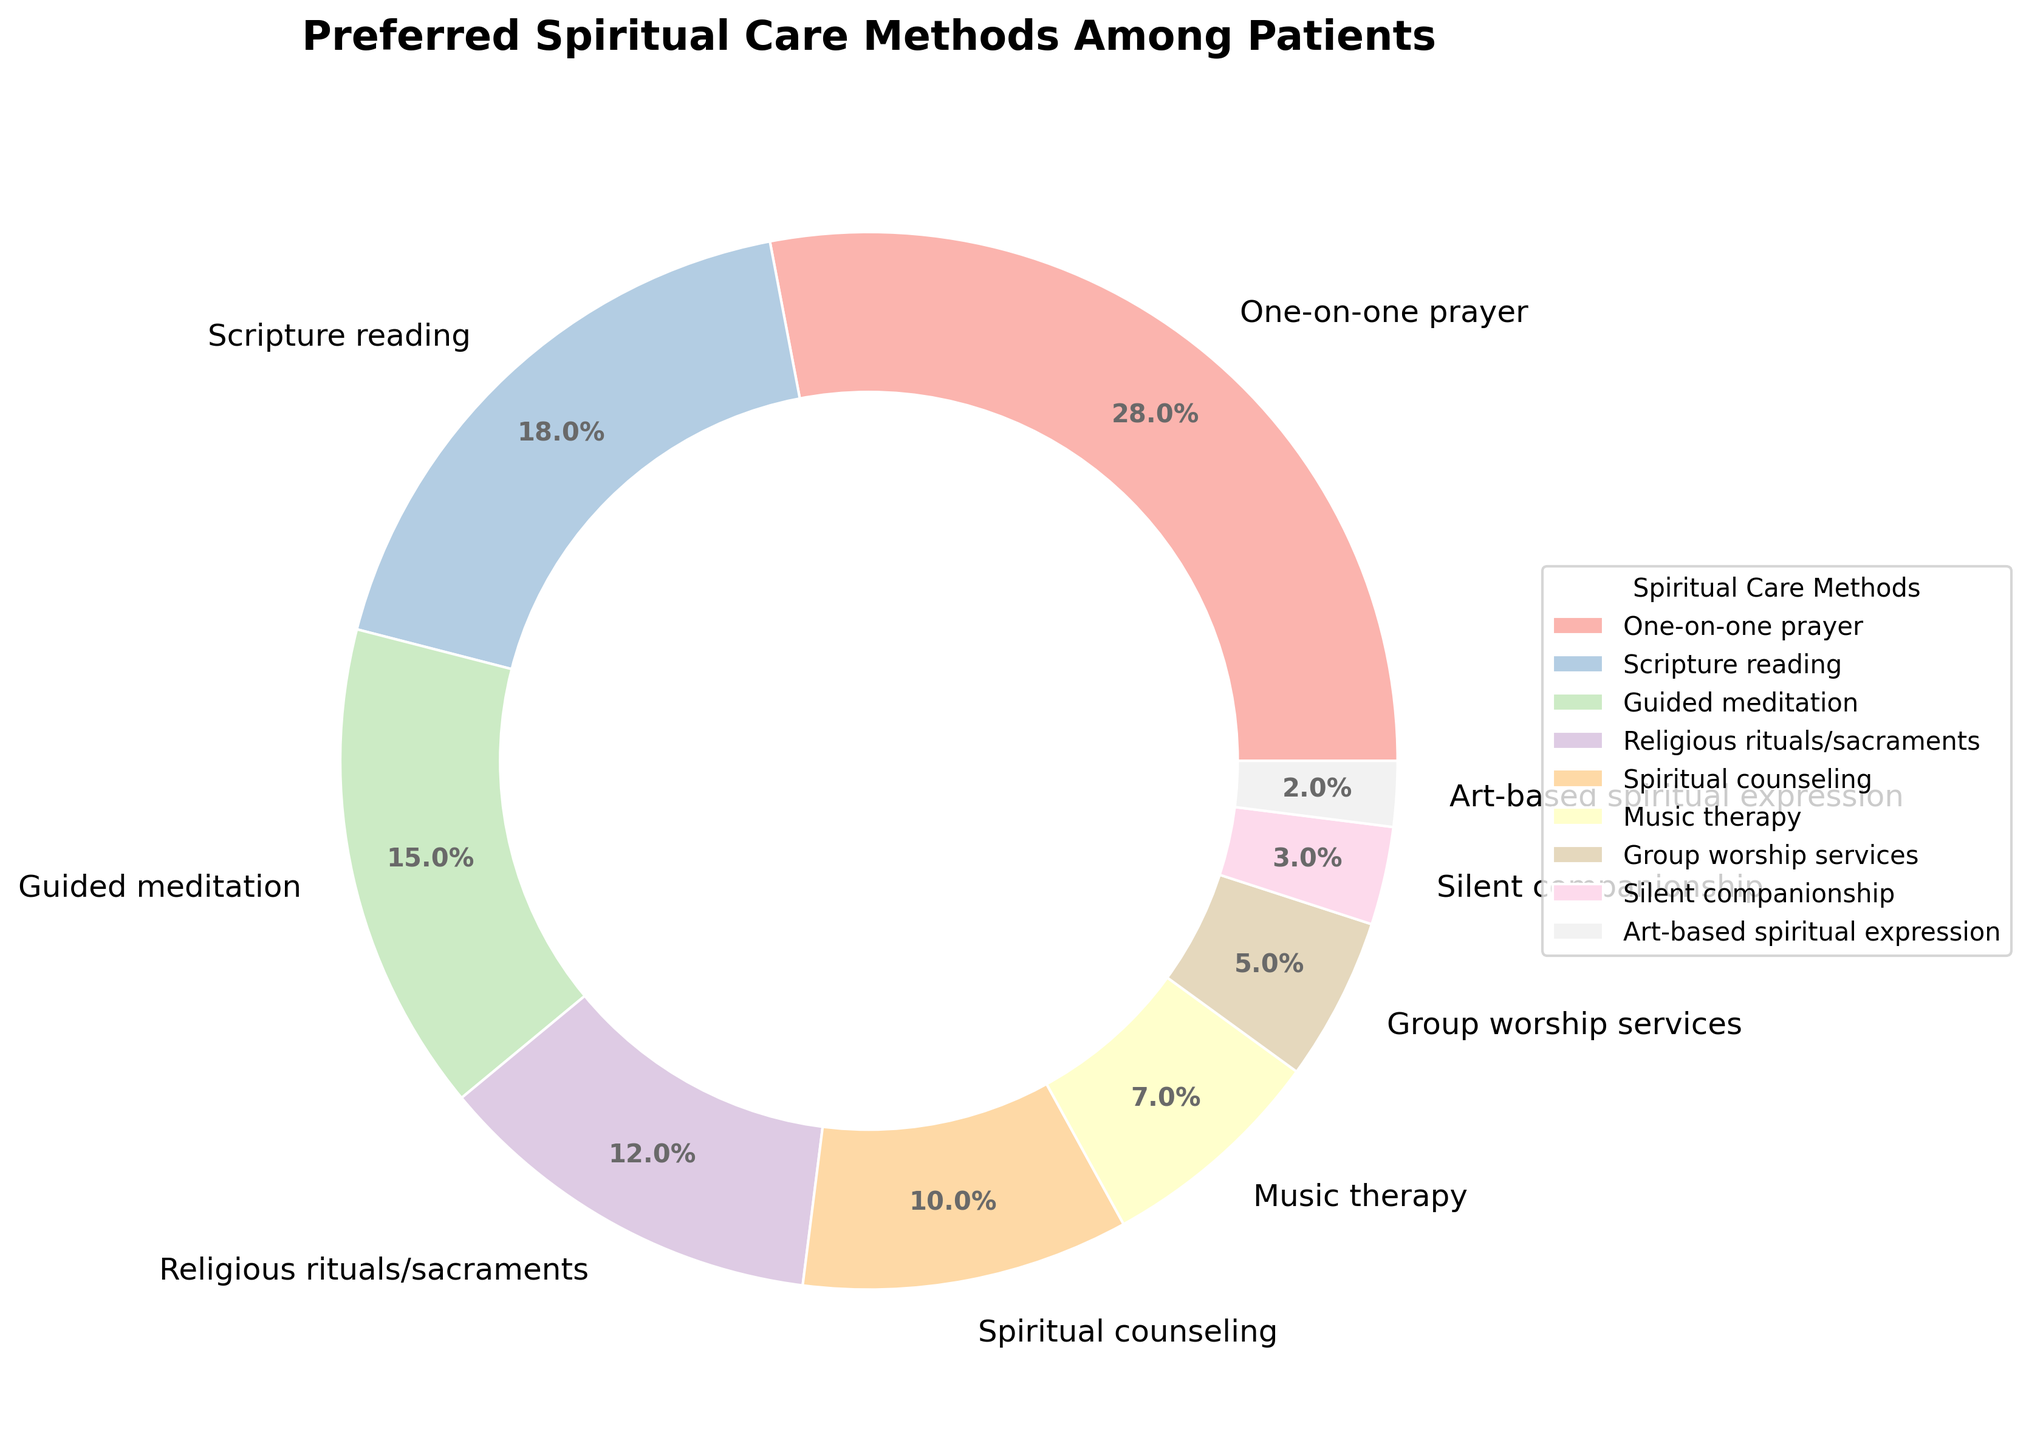What's the most preferred spiritual care method among patients? According to the pie chart, the section labeled "One-on-one prayer" has the largest proportion.
Answer: One-on-one prayer What's the least preferred method of spiritual care among patients? The pie chart shows that "Art-based spiritual expression" occupies the smallest portion.
Answer: Art-based spiritual expression How much more popular is scripture reading compared to music therapy? The percentage of patients preferring Scripture reading is 18%, while 7% prefer Music therapy. The difference is 18% - 7% = 11%.
Answer: 11% What percentage of patients prefer guided meditation and spiritual counseling combined? Adding the percentages for Guided meditation (15%) and Spiritual counseling (10%) gives 15% + 10% = 25%.
Answer: 25% Which method has a lower preference: group worship services or silent companionship? According to the pie chart, "Silent companionship" has a smaller proportion at 3%, compared to "Group worship services" at 5%.
Answer: Silent companionship How many methods have a preference greater than 10%? Observing the pie chart, we see that "One-on-one prayer" (28%), "Scripture reading" (18%), "Guided meditation" (15%), and "Religious rituals/sacraments" (12%) are all greater than 10%. This sums to 4 methods.
Answer: 4 What is the average percentage preference for the methods Music therapy, Group worship services, and Silent companionship? Adding the percentages for Music therapy (7%), Group worship services (5%), and Silent companionship (3%) gives a total of 15%. Dividing by the number of methods (3) gives 15% / 3 = 5%.
Answer: 5% Which visual attributes help identify the most preferred method in the pie chart? The most preferred method has the largest wedge in the pie chart, set apart by both size and a distinct color. In this case, "One-on-one prayer" occupies the largest segment visually.
Answer: Largest wedge and distinct color Is the preference for art-based spiritual expression closer to that for silent companionship or music therapy? Art-based spiritual expression is 2%, silent companionship is 3%, and music therapy is 7%. The difference between art-based and silent companionship is 1%, whereas it's 5% compared to music therapy. Therefore, it's closer to silent companionship.
Answer: Silent companionship What is the combined preference for less popular methods (those below 10%)? Adding the percentages of Silent companionship (3%), Art-based spiritual expression (2%), and Group worship services (5%) results in 3% + 2% + 5% = 10%.
Answer: 10% 